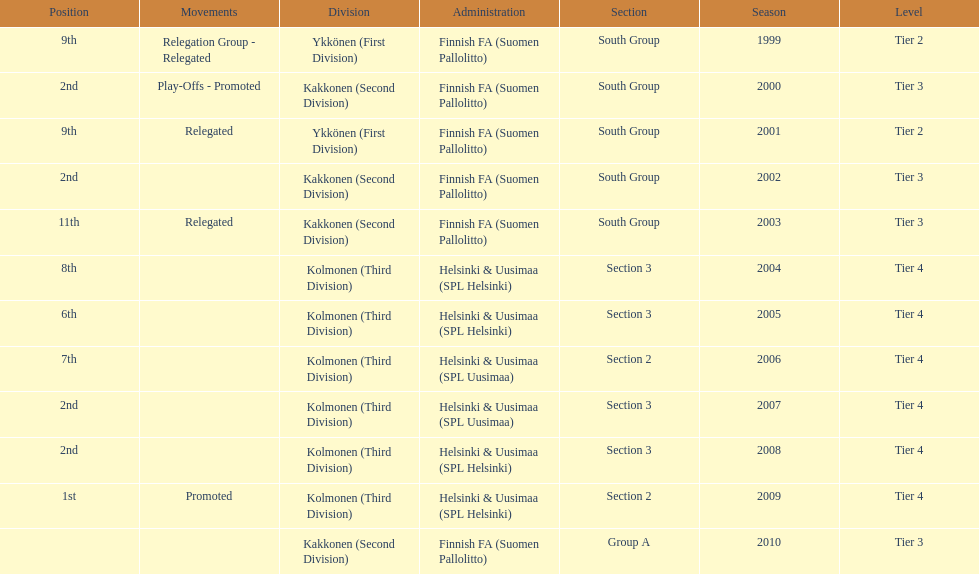How many 2nd positions were there? 4. 